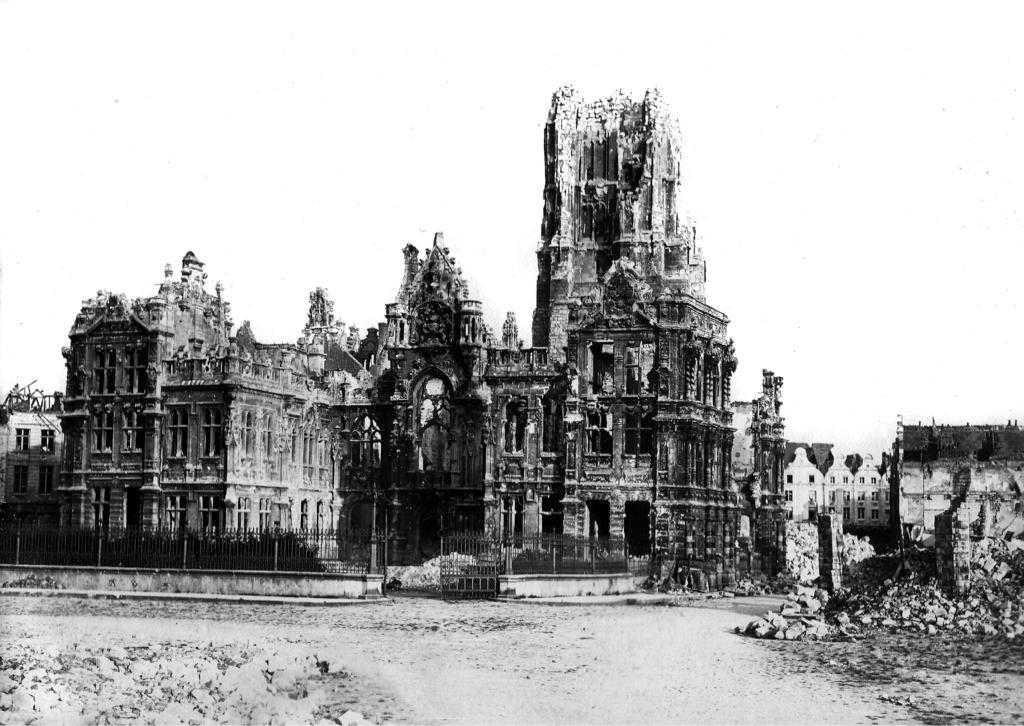What is the main subject in the center of the image? There is a monument in the center of the image. What is located in front of the monument? There is a boundary in front of the monument. What type of natural elements can be seen at the bottom side of the image? There are rocks at the bottom side of the image. What is the taste of the rocks at the bottom side of the image? Rocks do not have a taste, so this question cannot be answered. 